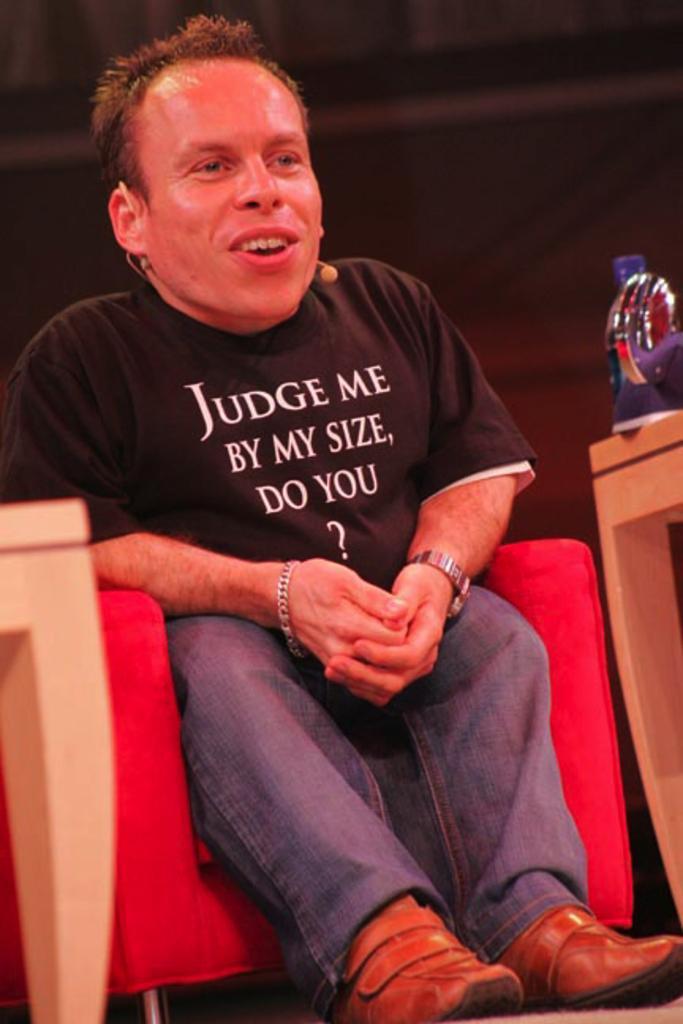How would you summarize this image in a sentence or two? In this image there is a man sitting in a sofa. He is wearing black t-shirt and blue jeans. Beside him there is a table, on which a coke bottle is kept. And he is wearing brown shoes. 